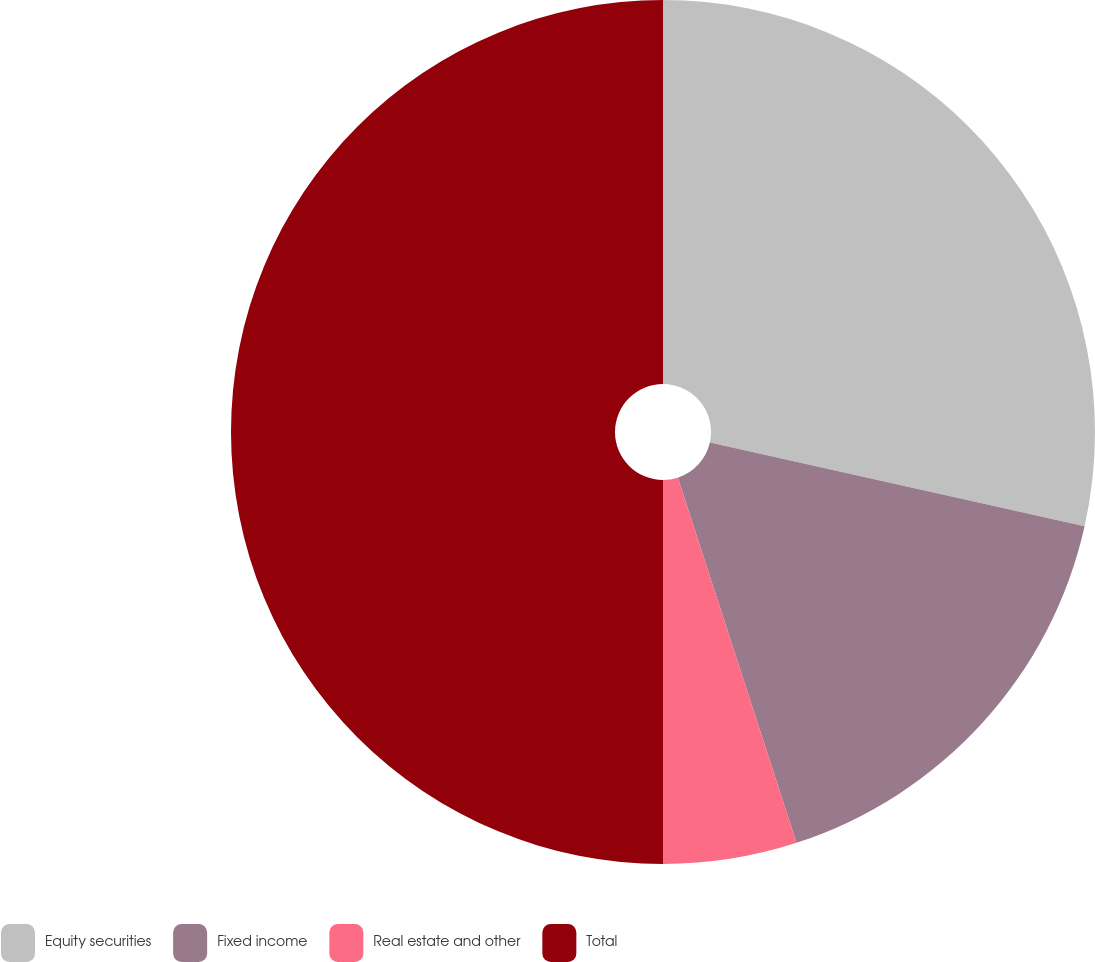Convert chart to OTSL. <chart><loc_0><loc_0><loc_500><loc_500><pie_chart><fcel>Equity securities<fcel>Fixed income<fcel>Real estate and other<fcel>Total<nl><fcel>28.5%<fcel>16.5%<fcel>5.0%<fcel>50.0%<nl></chart> 